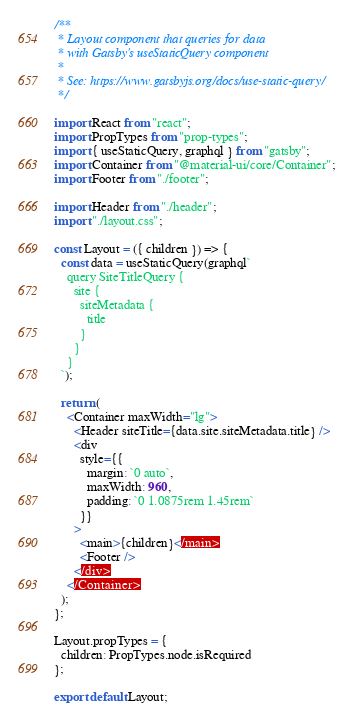Convert code to text. <code><loc_0><loc_0><loc_500><loc_500><_JavaScript_>/**
 * Layout component that queries for data
 * with Gatsby's useStaticQuery component
 *
 * See: https://www.gatsbyjs.org/docs/use-static-query/
 */

import React from "react";
import PropTypes from "prop-types";
import { useStaticQuery, graphql } from "gatsby";
import Container from "@material-ui/core/Container";
import Footer from "./footer";

import Header from "./header";
import "./layout.css";

const Layout = ({ children }) => {
  const data = useStaticQuery(graphql`
    query SiteTitleQuery {
      site {
        siteMetadata {
          title
        }
      }
    }
  `);

  return (
    <Container maxWidth="lg">
      <Header siteTitle={data.site.siteMetadata.title} />
      <div
        style={{
          margin: `0 auto`,
          maxWidth: 960,
          padding: `0 1.0875rem 1.45rem`
        }}
      >
        <main>{children}</main>
        <Footer />
      </div>
    </Container>
  );
};

Layout.propTypes = {
  children: PropTypes.node.isRequired
};

export default Layout;
</code> 